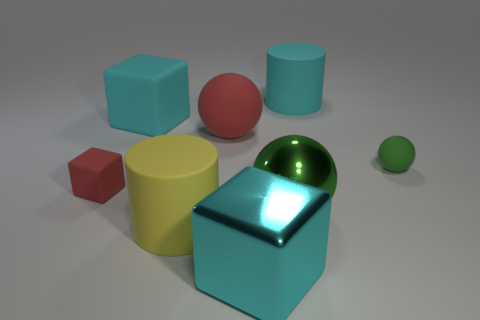Add 1 red objects. How many objects exist? 9 Subtract all blocks. How many objects are left? 5 Subtract 0 purple blocks. How many objects are left? 8 Subtract all rubber things. Subtract all cylinders. How many objects are left? 0 Add 4 large matte objects. How many large matte objects are left? 8 Add 2 large rubber balls. How many large rubber balls exist? 3 